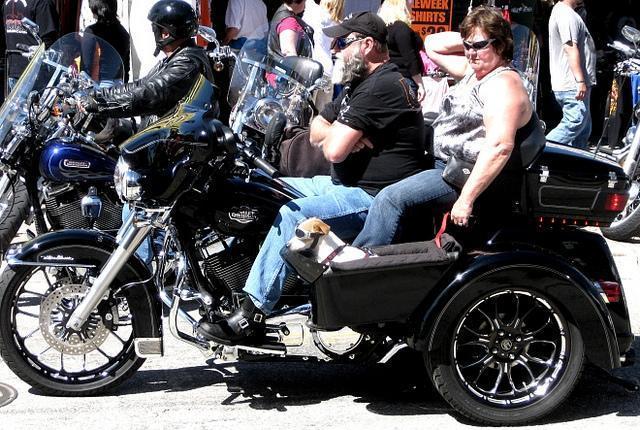How many riders are on the black motorcycle?
Give a very brief answer. 2. How many tires does the bike have?
Give a very brief answer. 3. How many motorcycles can be seen?
Give a very brief answer. 4. How many people are there?
Give a very brief answer. 8. How many cars are shown?
Give a very brief answer. 0. 